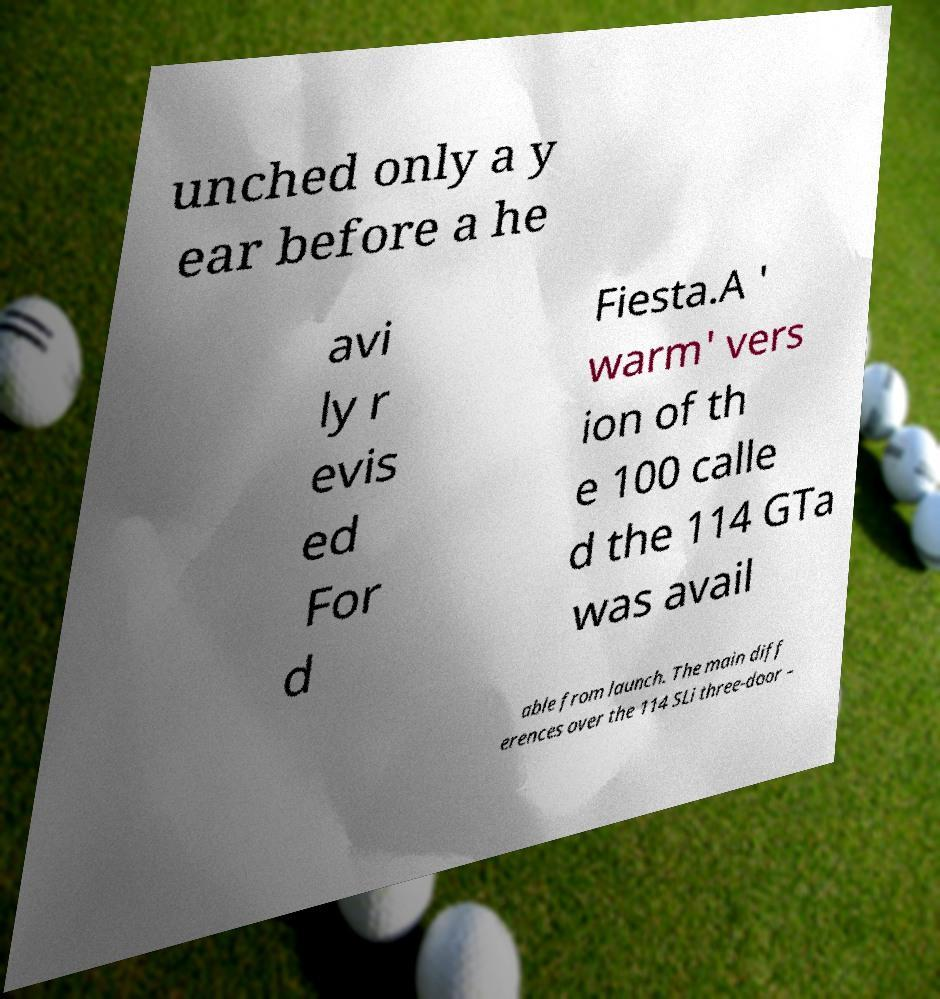I need the written content from this picture converted into text. Can you do that? unched only a y ear before a he avi ly r evis ed For d Fiesta.A ' warm' vers ion of th e 100 calle d the 114 GTa was avail able from launch. The main diff erences over the 114 SLi three-door – 